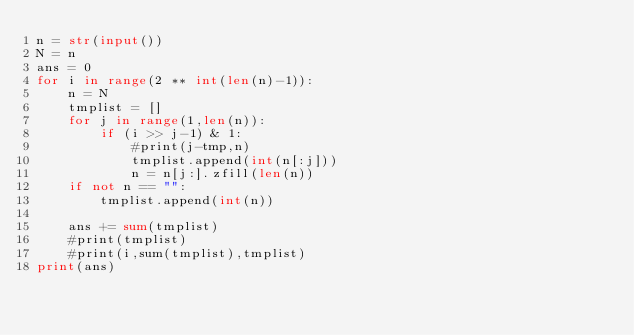Convert code to text. <code><loc_0><loc_0><loc_500><loc_500><_Python_>n = str(input())
N = n
ans = 0
for i in range(2 ** int(len(n)-1)):
    n = N
    tmplist = []
    for j in range(1,len(n)):
        if (i >> j-1) & 1:
            #print(j-tmp,n)
            tmplist.append(int(n[:j]))
            n = n[j:].zfill(len(n))
    if not n == "":
        tmplist.append(int(n))

    ans += sum(tmplist)
    #print(tmplist)
    #print(i,sum(tmplist),tmplist)
print(ans)</code> 